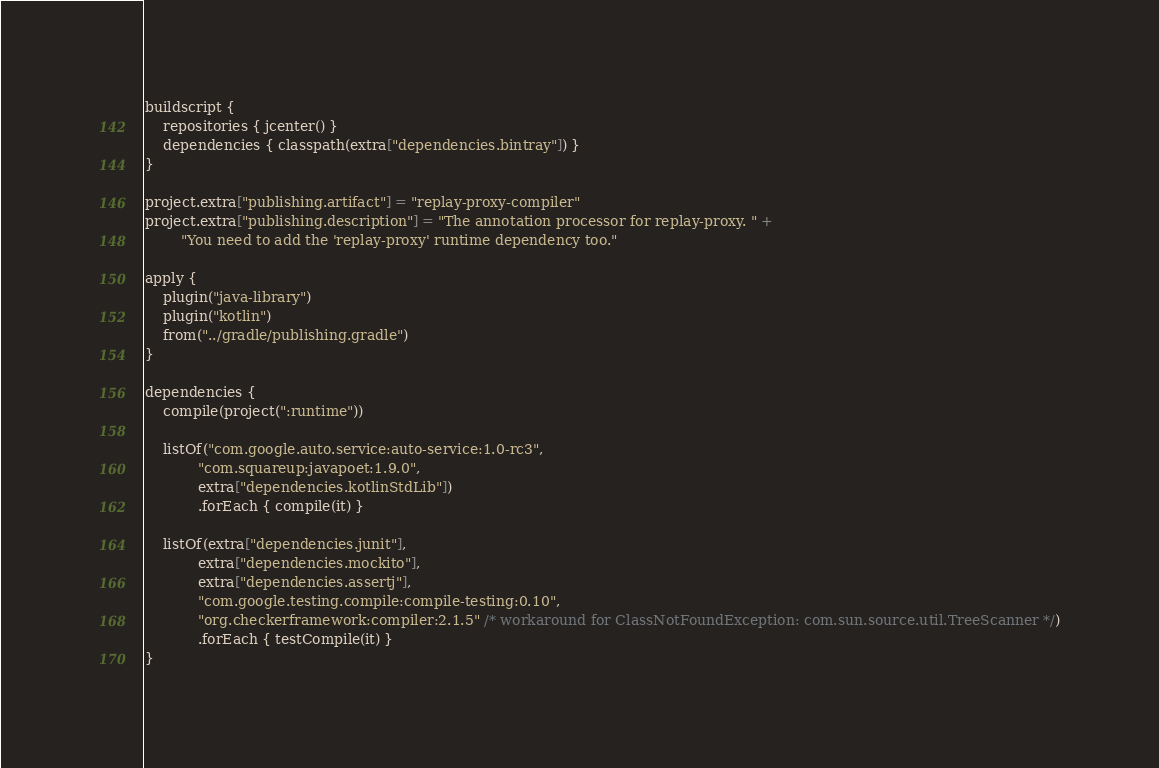<code> <loc_0><loc_0><loc_500><loc_500><_Kotlin_>buildscript {
    repositories { jcenter() }
    dependencies { classpath(extra["dependencies.bintray"]) }
}

project.extra["publishing.artifact"] = "replay-proxy-compiler"
project.extra["publishing.description"] = "The annotation processor for replay-proxy. " +
        "You need to add the 'replay-proxy' runtime dependency too."

apply {
    plugin("java-library")
    plugin("kotlin")
    from("../gradle/publishing.gradle")
}

dependencies {
    compile(project(":runtime"))

    listOf("com.google.auto.service:auto-service:1.0-rc3",
            "com.squareup:javapoet:1.9.0",
            extra["dependencies.kotlinStdLib"])
            .forEach { compile(it) }

    listOf(extra["dependencies.junit"],
            extra["dependencies.mockito"],
            extra["dependencies.assertj"],
            "com.google.testing.compile:compile-testing:0.10",
            "org.checkerframework:compiler:2.1.5" /* workaround for ClassNotFoundException: com.sun.source.util.TreeScanner */)
            .forEach { testCompile(it) }
}
</code> 